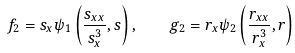Convert formula to latex. <formula><loc_0><loc_0><loc_500><loc_500>f _ { 2 } = s _ { x } \psi _ { 1 } \left ( \frac { s _ { x x } } { s ^ { 3 } _ { x } } , s \right ) , \quad g _ { 2 } = r _ { x } \psi _ { 2 } \left ( \frac { r _ { x x } } { r ^ { 3 } _ { x } } , r \right )</formula> 